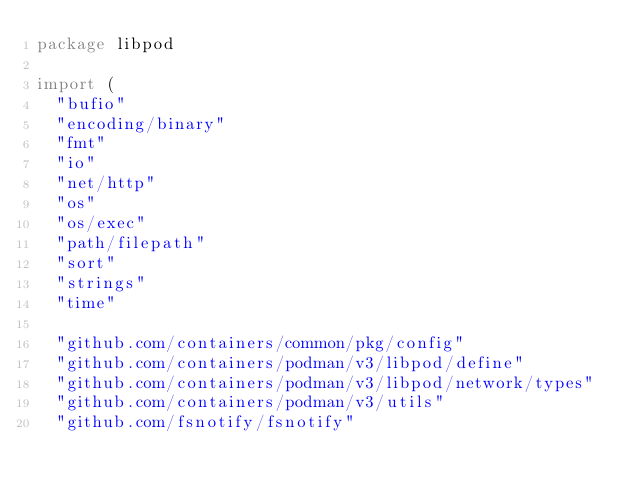Convert code to text. <code><loc_0><loc_0><loc_500><loc_500><_Go_>package libpod

import (
	"bufio"
	"encoding/binary"
	"fmt"
	"io"
	"net/http"
	"os"
	"os/exec"
	"path/filepath"
	"sort"
	"strings"
	"time"

	"github.com/containers/common/pkg/config"
	"github.com/containers/podman/v3/libpod/define"
	"github.com/containers/podman/v3/libpod/network/types"
	"github.com/containers/podman/v3/utils"
	"github.com/fsnotify/fsnotify"</code> 